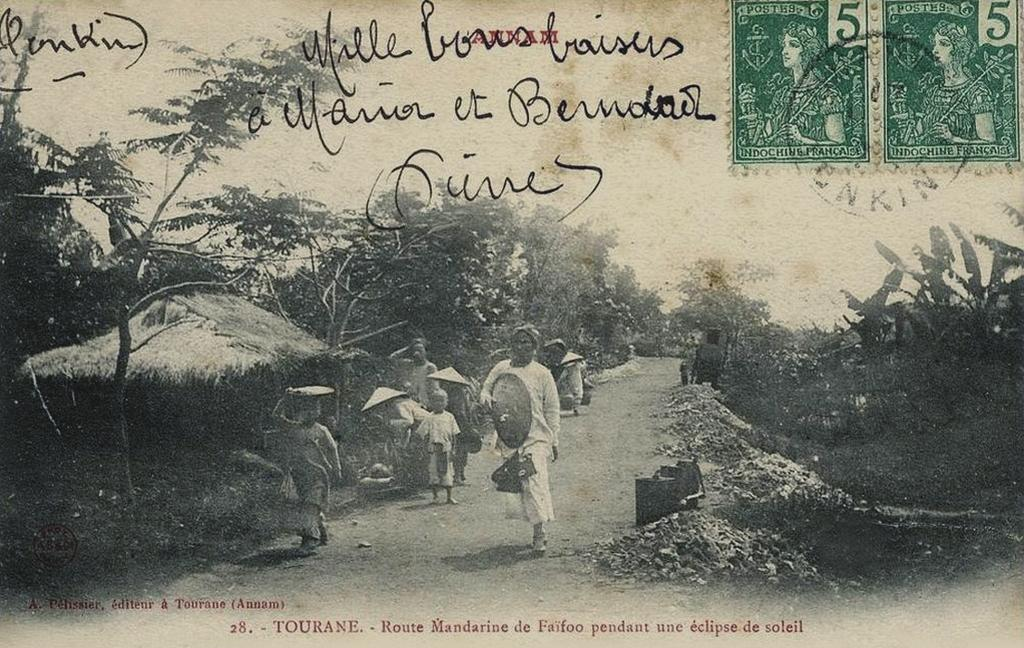What is the main subject of the paper in the image? The paper contains drawings of huts, trees, plants, and people. Can you describe the drawings of trees on the paper? The paper contains drawings of trees. What other types of drawings are present on the paper? The paper also contains drawings of plants and people. How is the sky depicted on the paper? The sky is depicted on the paper. What type of cabbage is being used to draw on the paper? There is no cabbage present in the image; the drawings are made with a pen or pencil, not a vegetable. How does the ink on the paper affect the hearing of the people depicted? There is no ink mentioned in the image, and the drawings do not have any auditory effects on the people depicted. 